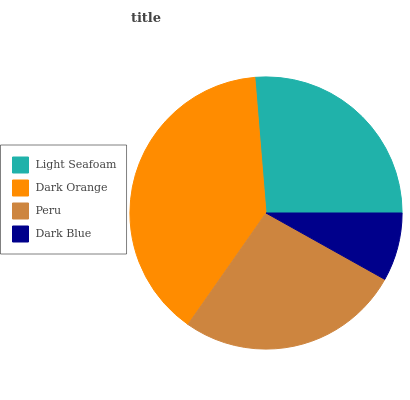Is Dark Blue the minimum?
Answer yes or no. Yes. Is Dark Orange the maximum?
Answer yes or no. Yes. Is Peru the minimum?
Answer yes or no. No. Is Peru the maximum?
Answer yes or no. No. Is Dark Orange greater than Peru?
Answer yes or no. Yes. Is Peru less than Dark Orange?
Answer yes or no. Yes. Is Peru greater than Dark Orange?
Answer yes or no. No. Is Dark Orange less than Peru?
Answer yes or no. No. Is Peru the high median?
Answer yes or no. Yes. Is Light Seafoam the low median?
Answer yes or no. Yes. Is Dark Orange the high median?
Answer yes or no. No. Is Dark Orange the low median?
Answer yes or no. No. 